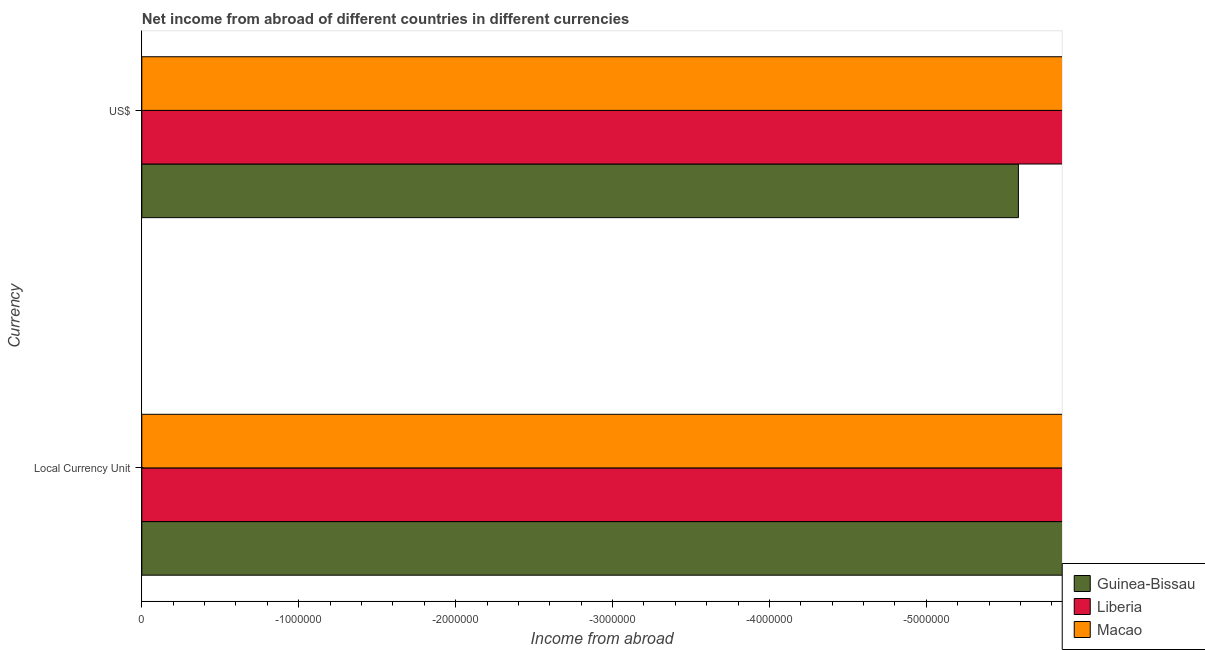How many different coloured bars are there?
Give a very brief answer. 0. What is the label of the 2nd group of bars from the top?
Provide a short and direct response. Local Currency Unit. What is the income from abroad in us$ in Guinea-Bissau?
Give a very brief answer. 0. In how many countries, is the income from abroad in us$ greater than -3200000 units?
Offer a very short reply. 0. In how many countries, is the income from abroad in us$ greater than the average income from abroad in us$ taken over all countries?
Make the answer very short. 0. How many bars are there?
Keep it short and to the point. 0. Are all the bars in the graph horizontal?
Offer a terse response. Yes. What is the difference between two consecutive major ticks on the X-axis?
Ensure brevity in your answer.  1.00e+06. Does the graph contain any zero values?
Offer a very short reply. Yes. Where does the legend appear in the graph?
Your answer should be very brief. Bottom right. How many legend labels are there?
Keep it short and to the point. 3. What is the title of the graph?
Give a very brief answer. Net income from abroad of different countries in different currencies. What is the label or title of the X-axis?
Your answer should be compact. Income from abroad. What is the label or title of the Y-axis?
Provide a short and direct response. Currency. What is the Income from abroad of Liberia in Local Currency Unit?
Provide a succinct answer. 0. What is the Income from abroad of Macao in Local Currency Unit?
Your answer should be compact. 0. What is the Income from abroad of Macao in US$?
Your answer should be very brief. 0. What is the total Income from abroad in Guinea-Bissau in the graph?
Your response must be concise. 0. What is the average Income from abroad in Guinea-Bissau per Currency?
Your response must be concise. 0. What is the average Income from abroad of Macao per Currency?
Provide a succinct answer. 0. 